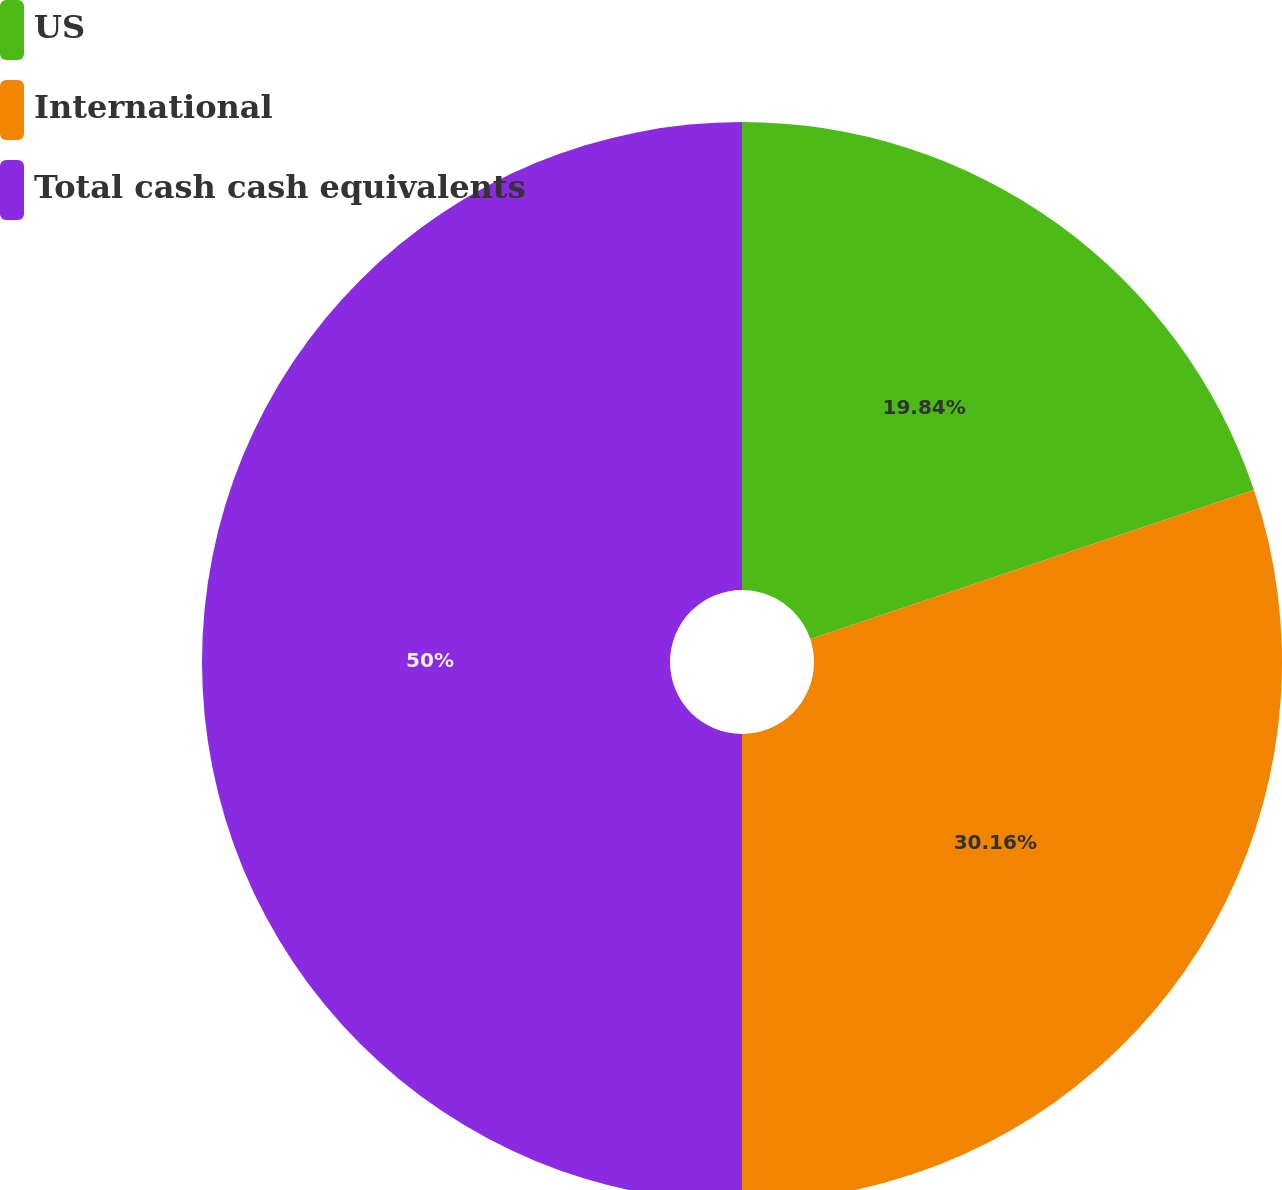Convert chart. <chart><loc_0><loc_0><loc_500><loc_500><pie_chart><fcel>US<fcel>International<fcel>Total cash cash equivalents<nl><fcel>19.84%<fcel>30.16%<fcel>50.0%<nl></chart> 